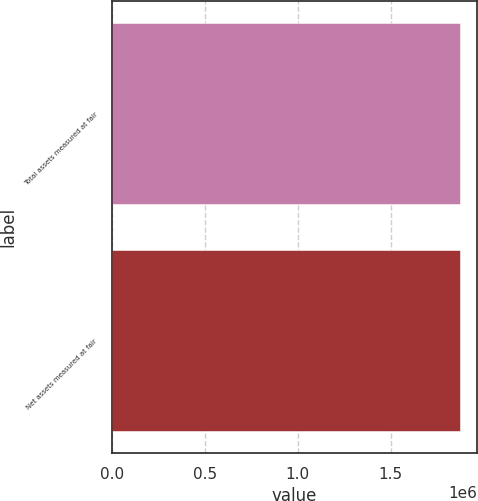<chart> <loc_0><loc_0><loc_500><loc_500><bar_chart><fcel>Total assets measured at fair<fcel>Net assets measured at fair<nl><fcel>1.87384e+06<fcel>1.87151e+06<nl></chart> 